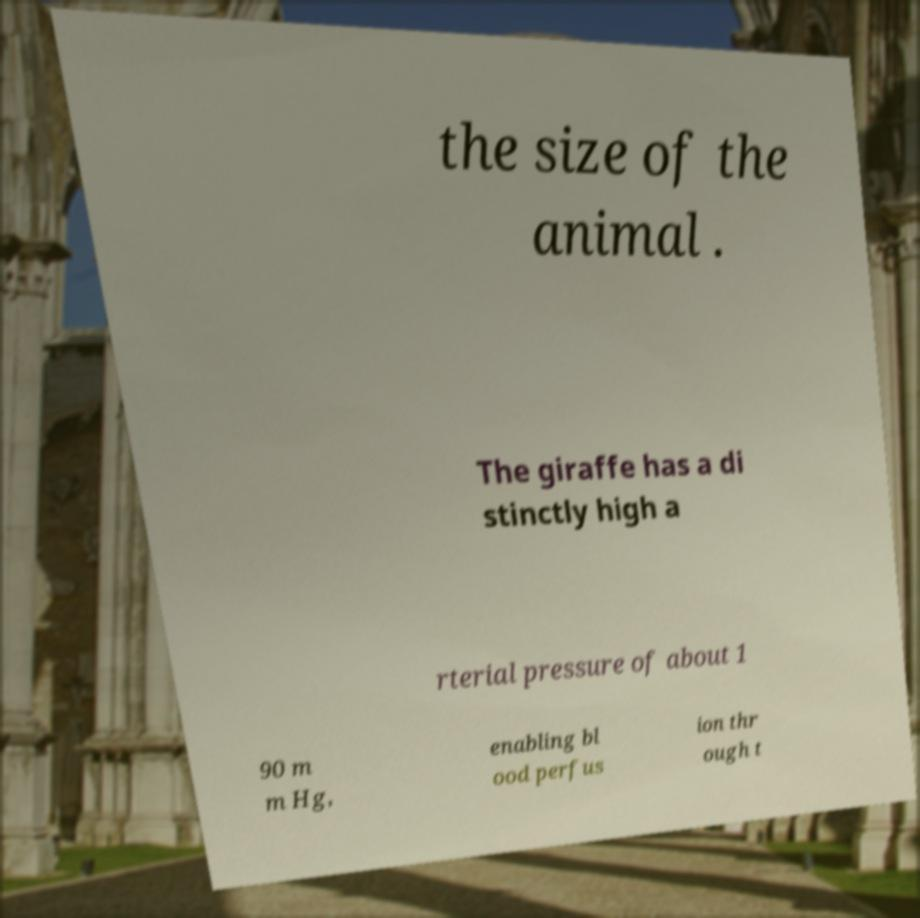Can you accurately transcribe the text from the provided image for me? the size of the animal . The giraffe has a di stinctly high a rterial pressure of about 1 90 m m Hg, enabling bl ood perfus ion thr ough t 